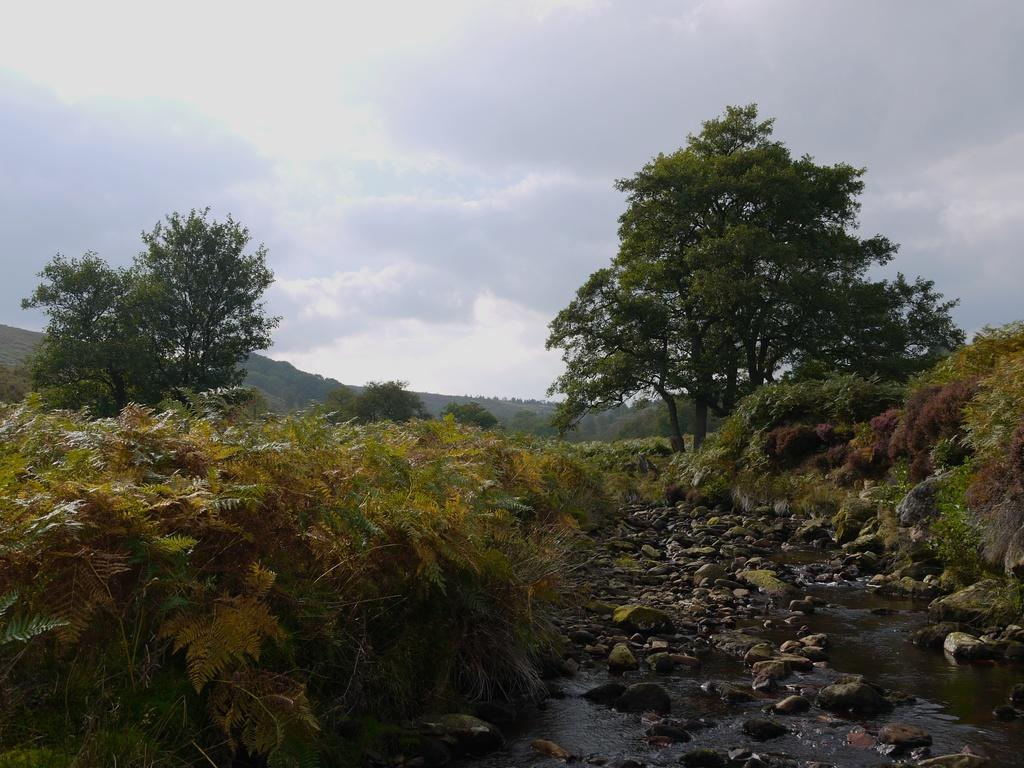What is the primary element in the image? There is running water in the image. What type of natural objects can be seen in the image? There are stones, plants, bushes, trees, and hills visible in the image. What is visible in the sky in the image? The sky is visible in the image, and clouds are present. How many beds can be seen in the image? There are no beds present in the image. What type of laughter can be heard coming from the trees in the image? There is no laughter present in the image, as it is a still image and does not contain any sounds. 